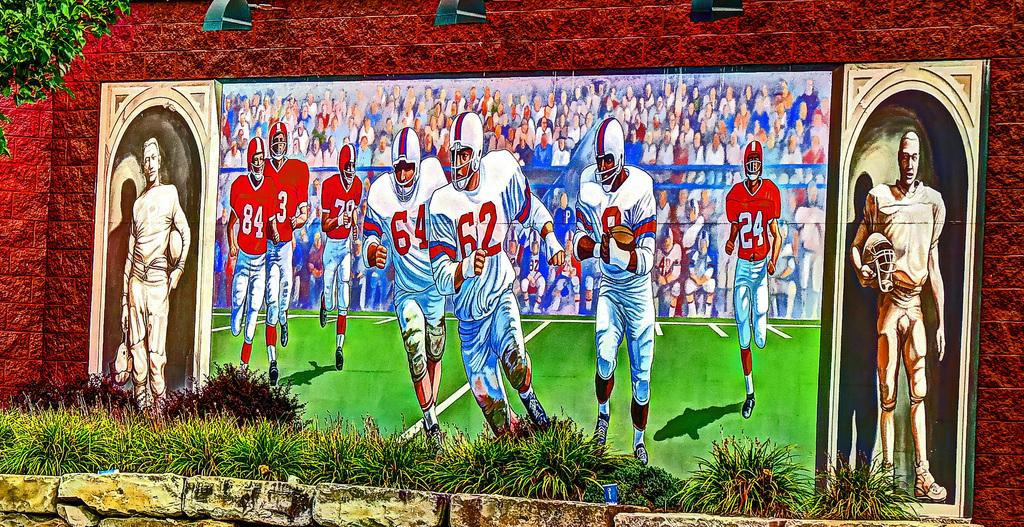What is the main subject of the painting in the image? The painting depicts football players. What is the background of the painting? The painting is in front of a red brick wall. What type of surface is shown in the painting? The painting has a grass surface. What is the process of creating the yard in the image? There is no yard present in the image; it features a painting of football players in front of a red brick wall. 